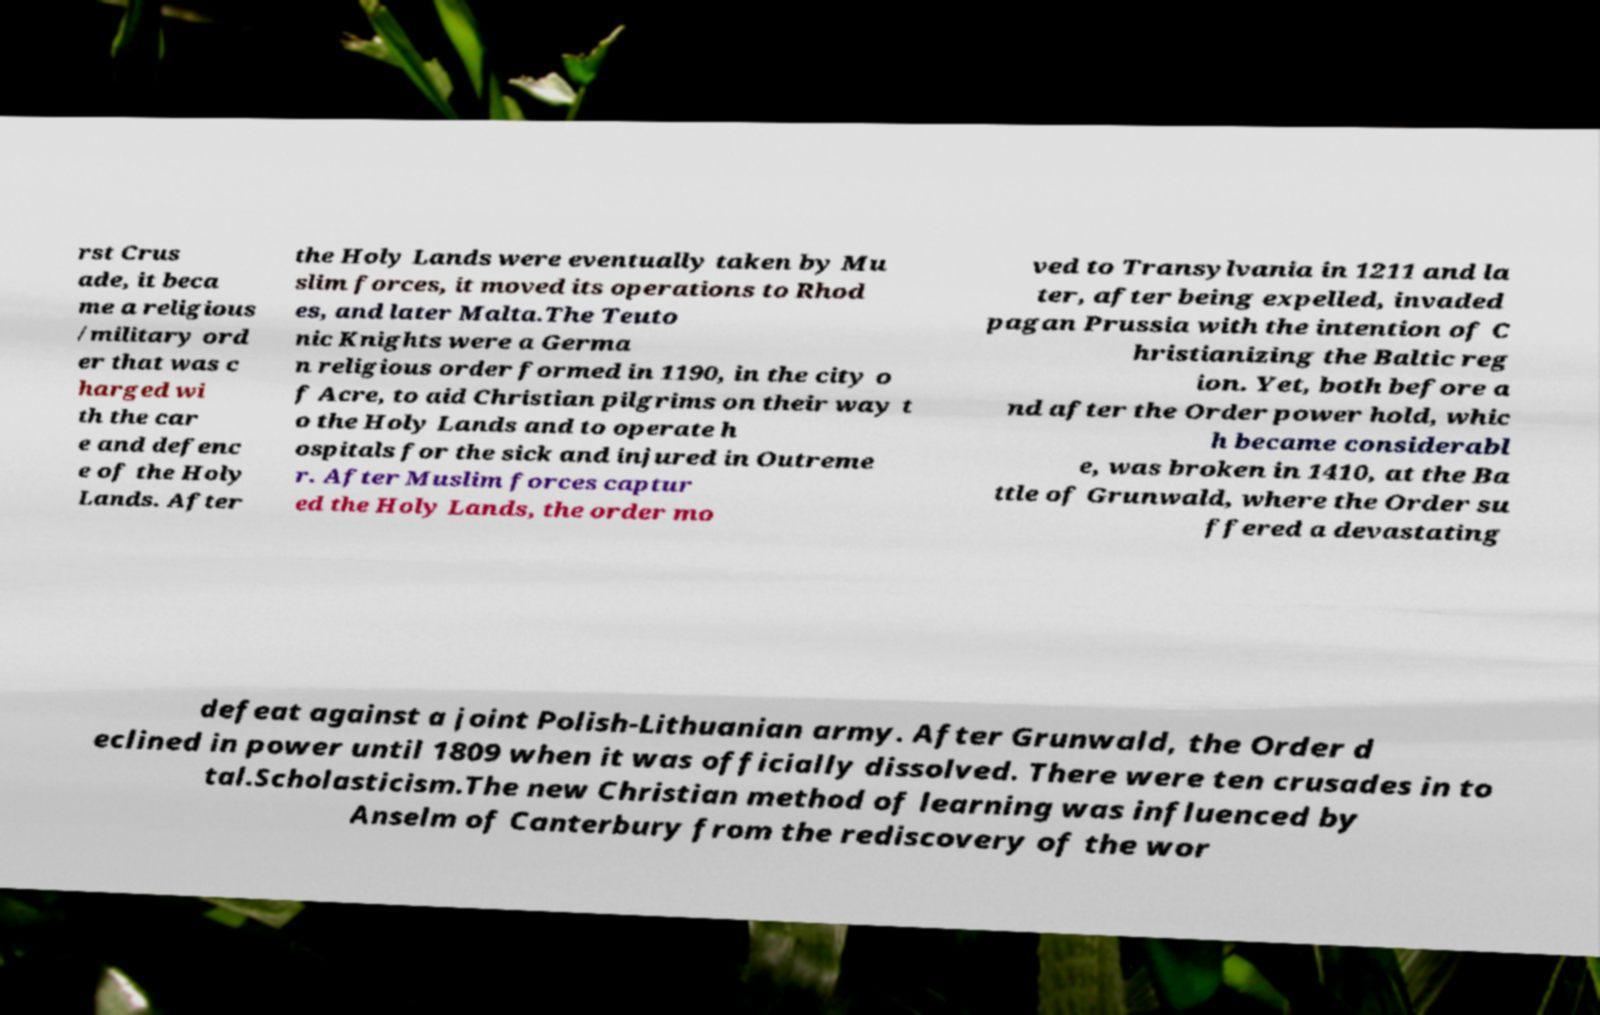What messages or text are displayed in this image? I need them in a readable, typed format. rst Crus ade, it beca me a religious /military ord er that was c harged wi th the car e and defenc e of the Holy Lands. After the Holy Lands were eventually taken by Mu slim forces, it moved its operations to Rhod es, and later Malta.The Teuto nic Knights were a Germa n religious order formed in 1190, in the city o f Acre, to aid Christian pilgrims on their way t o the Holy Lands and to operate h ospitals for the sick and injured in Outreme r. After Muslim forces captur ed the Holy Lands, the order mo ved to Transylvania in 1211 and la ter, after being expelled, invaded pagan Prussia with the intention of C hristianizing the Baltic reg ion. Yet, both before a nd after the Order power hold, whic h became considerabl e, was broken in 1410, at the Ba ttle of Grunwald, where the Order su ffered a devastating defeat against a joint Polish-Lithuanian army. After Grunwald, the Order d eclined in power until 1809 when it was officially dissolved. There were ten crusades in to tal.Scholasticism.The new Christian method of learning was influenced by Anselm of Canterbury from the rediscovery of the wor 